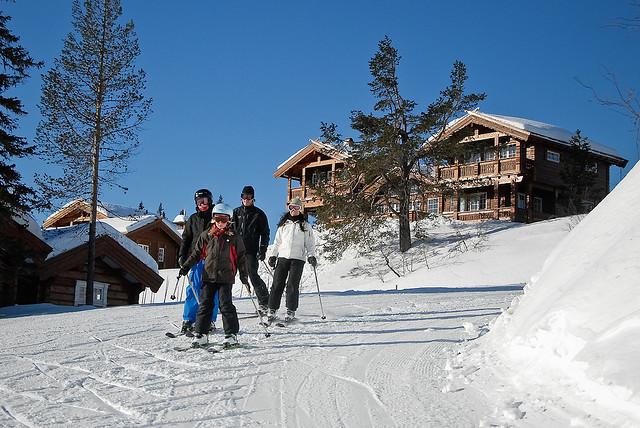Is it light outside?
Quick response, please. Yes. What covers the ground?
Keep it brief. Snow. What are the people doing?
Quick response, please. Skiing. What is that left person doing?
Keep it brief. Skiing. 